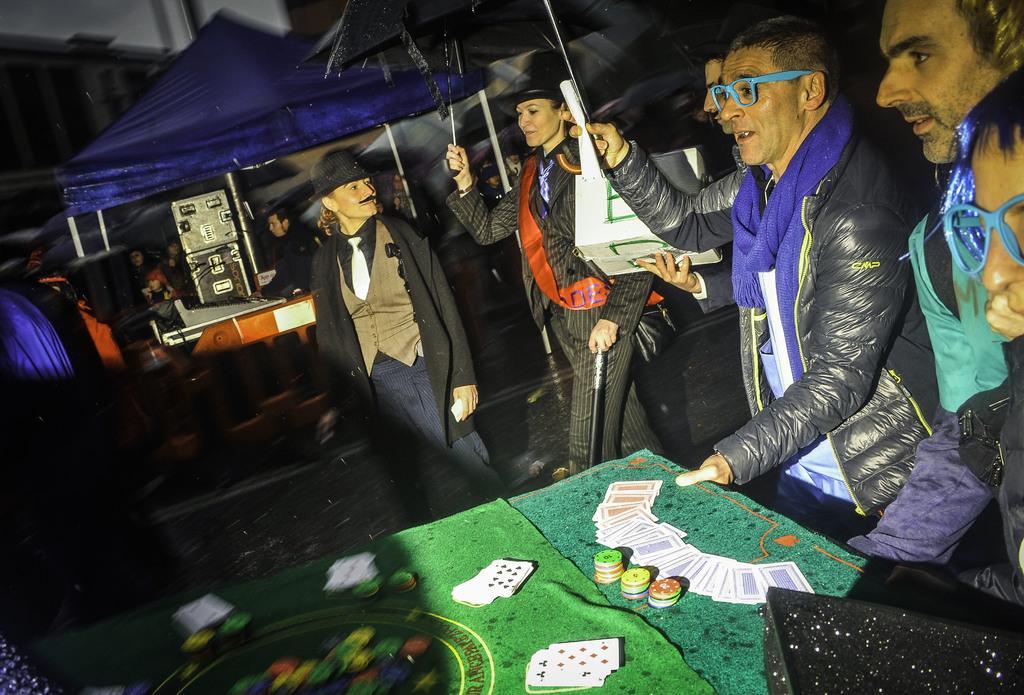Describe this image in one or two sentences. At the bottom of the image we can see a table. On the table we can see a cloth, cards, coins. Beside the table we can see some persons are standing. In the center of the image we can see two ladies are standing and wearing costume and a lady is holding an umbrella and stick. In the background of the image we can see a tent, speakers, table and some persons. 